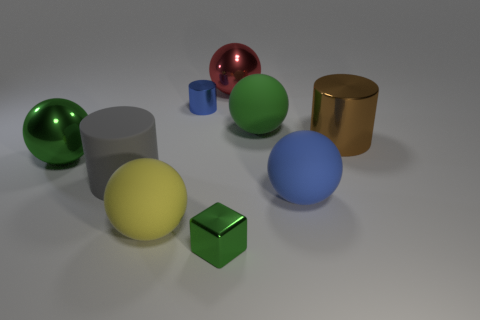What number of other things are the same color as the cube?
Ensure brevity in your answer.  2. Are there any metal balls that have the same color as the metal cube?
Offer a terse response. Yes. There is a metallic ball behind the large green metal ball; does it have the same color as the small block?
Provide a succinct answer. No. How many things are green shiny things left of the small block or shiny cylinders?
Make the answer very short. 3. There is a large red sphere; are there any brown metal things to the left of it?
Make the answer very short. No. There is a ball that is the same color as the small cylinder; what is its material?
Give a very brief answer. Rubber. Does the green sphere left of the big red ball have the same material as the large brown cylinder?
Provide a short and direct response. Yes. Is there a green metal thing that is in front of the large green sphere to the left of the large matte sphere behind the brown shiny object?
Provide a short and direct response. Yes. What number of blocks are either large green rubber objects or big blue matte objects?
Offer a very short reply. 0. There is a large green ball left of the red object; what material is it?
Your answer should be compact. Metal. 